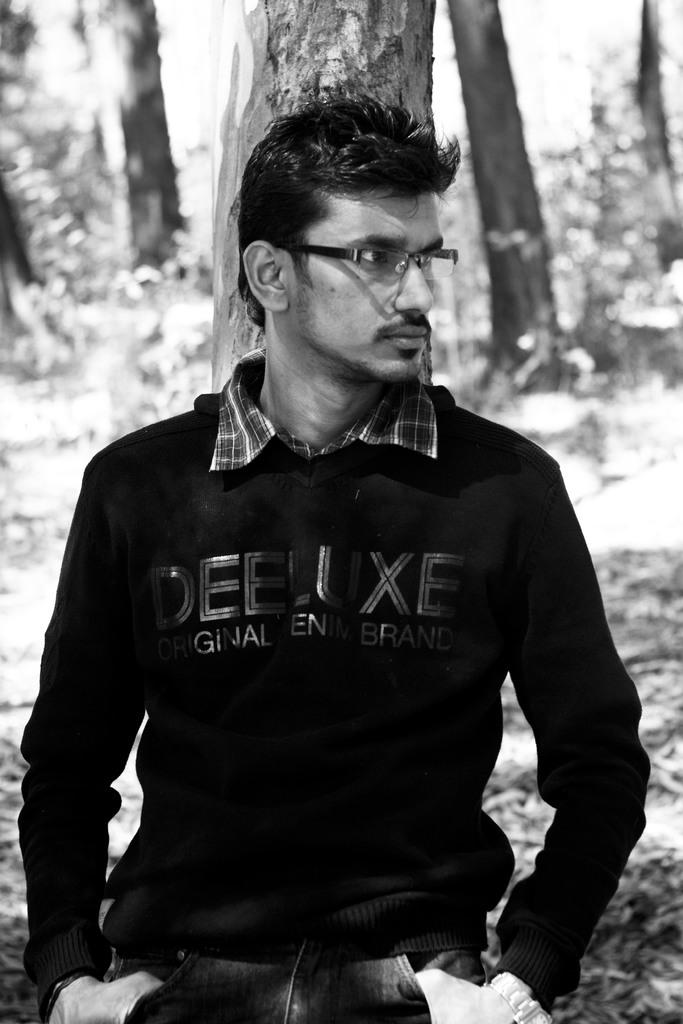What is the color scheme of the image? The image is black and white. Who or what can be seen in the image? There is a man in the image. Where is the man located in the image? The man is standing by a tree. What is unusual characteristic does the tree have in the image? The tree is laying down. What type of grain is being harvested in the image? There is no grain or harvesting activity present in the image. What part of the man's body is visible in the image? The image is black and white, and it is not possible to determine the specific body parts visible. 